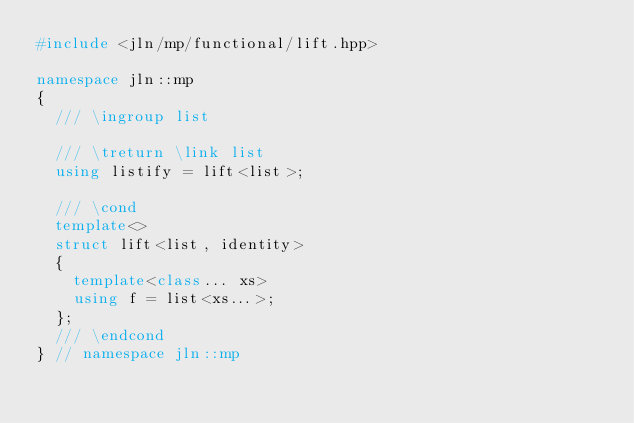Convert code to text. <code><loc_0><loc_0><loc_500><loc_500><_C++_>#include <jln/mp/functional/lift.hpp>

namespace jln::mp
{
  /// \ingroup list

  /// \treturn \link list
  using listify = lift<list>;

  /// \cond
  template<>
  struct lift<list, identity>
  {
    template<class... xs>
    using f = list<xs...>;
  };
  /// \endcond
} // namespace jln::mp
</code> 